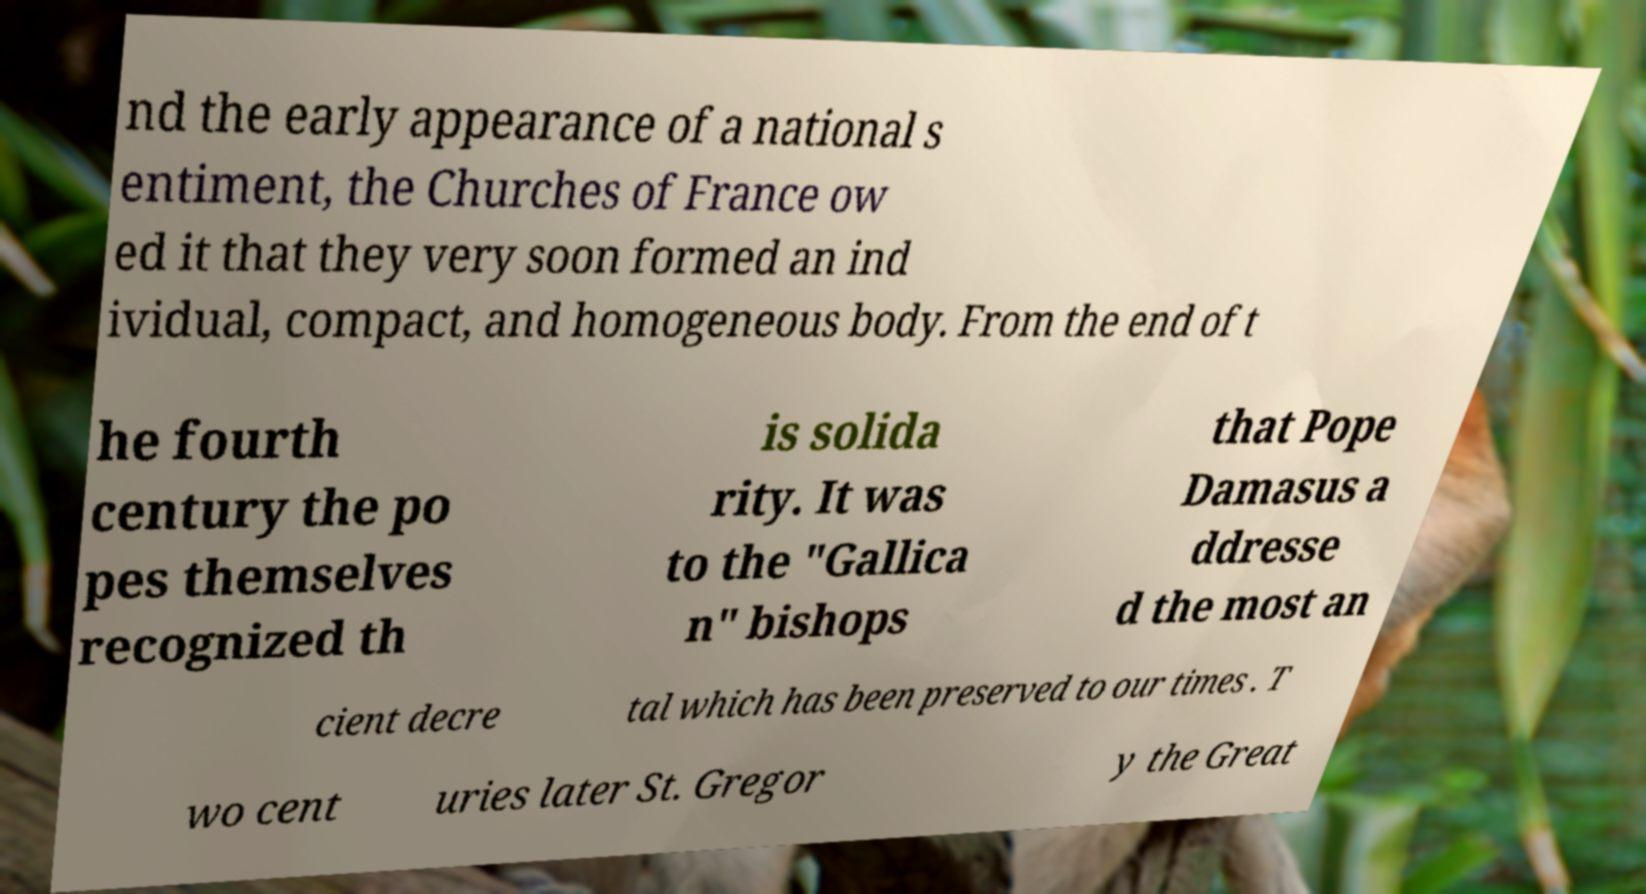Can you accurately transcribe the text from the provided image for me? nd the early appearance of a national s entiment, the Churches of France ow ed it that they very soon formed an ind ividual, compact, and homogeneous body. From the end of t he fourth century the po pes themselves recognized th is solida rity. It was to the "Gallica n" bishops that Pope Damasus a ddresse d the most an cient decre tal which has been preserved to our times . T wo cent uries later St. Gregor y the Great 